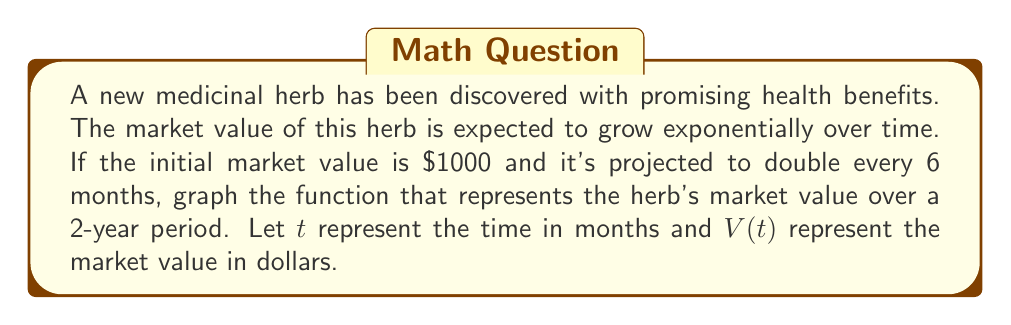What is the answer to this math problem? To graph the exponential growth of the herb's market value, we'll follow these steps:

1) First, let's identify the components of our exponential function:
   - Initial value: $a = 1000$
   - Growth rate: doubles every 6 months, so $r = 2$
   - Time period: 6 months

2) The general form of an exponential function is:
   $$ V(t) = a \cdot r^{\frac{t}{p}} $$
   where $p$ is the time period for one doubling.

3) Substituting our values:
   $$ V(t) = 1000 \cdot 2^{\frac{t}{6}} $$

4) To graph this function, we'll calculate some points:
   - At $t = 0$: $V(0) = 1000 \cdot 2^0 = 1000$
   - At $t = 6$: $V(6) = 1000 \cdot 2^1 = 2000$
   - At $t = 12$: $V(12) = 1000 \cdot 2^2 = 4000$
   - At $t = 18$: $V(18) = 1000 \cdot 2^3 = 8000$
   - At $t = 24$: $V(24) = 1000 \cdot 2^4 = 16000$

5) Now we can plot these points and connect them with a smooth curve:

[asy]
import graph;
size(200,200);
real f(real x) {return 1000*2^(x/6);}
xaxis("Time (months)",0,24,6);
yaxis("Value ($)",0,16000,4000);
draw(graph(f,0,24,operator ..));
label("$(0,1000)$",(0,1000),W);
label("$(6,2000)$",(6,2000),W);
label("$(12,4000)$",(12,4000),W);
label("$(18,8000)$",(18,8000),W);
label("$(24,16000)$",(24,16000),W);
[/asy]

This graph shows the exponential growth of the herb's market value over the 2-year (24-month) period.
Answer: $V(t) = 1000 \cdot 2^{\frac{t}{6}}$, where $t$ is time in months and $V(t)$ is value in dollars. 